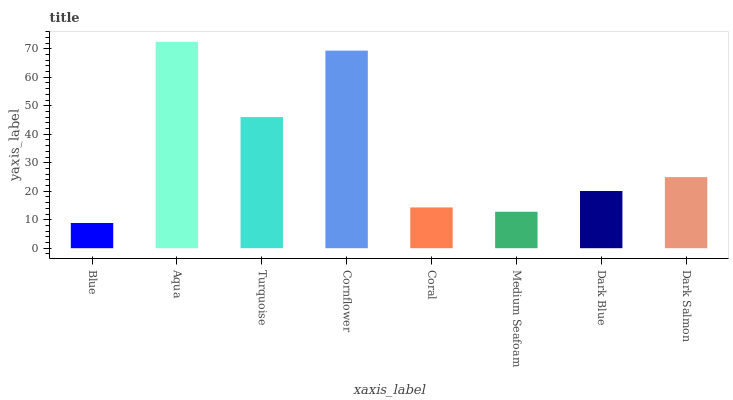Is Blue the minimum?
Answer yes or no. Yes. Is Aqua the maximum?
Answer yes or no. Yes. Is Turquoise the minimum?
Answer yes or no. No. Is Turquoise the maximum?
Answer yes or no. No. Is Aqua greater than Turquoise?
Answer yes or no. Yes. Is Turquoise less than Aqua?
Answer yes or no. Yes. Is Turquoise greater than Aqua?
Answer yes or no. No. Is Aqua less than Turquoise?
Answer yes or no. No. Is Dark Salmon the high median?
Answer yes or no. Yes. Is Dark Blue the low median?
Answer yes or no. Yes. Is Medium Seafoam the high median?
Answer yes or no. No. Is Dark Salmon the low median?
Answer yes or no. No. 